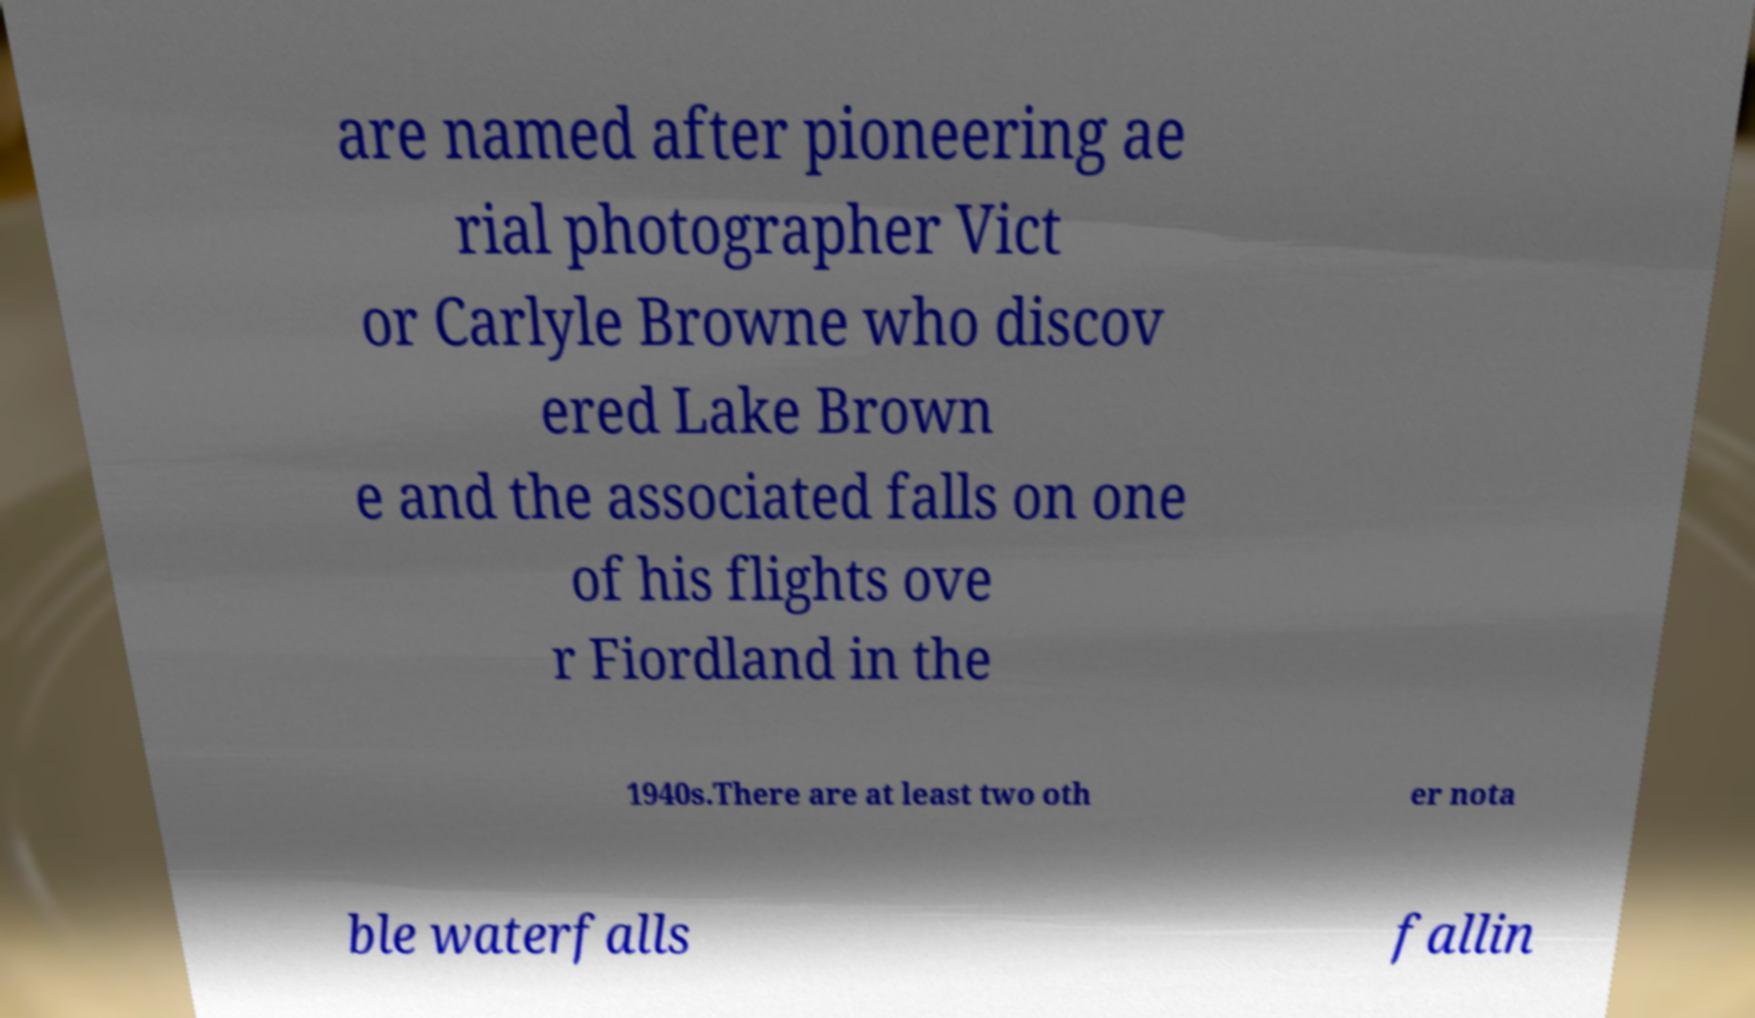Please read and relay the text visible in this image. What does it say? are named after pioneering ae rial photographer Vict or Carlyle Browne who discov ered Lake Brown e and the associated falls on one of his flights ove r Fiordland in the 1940s.There are at least two oth er nota ble waterfalls fallin 